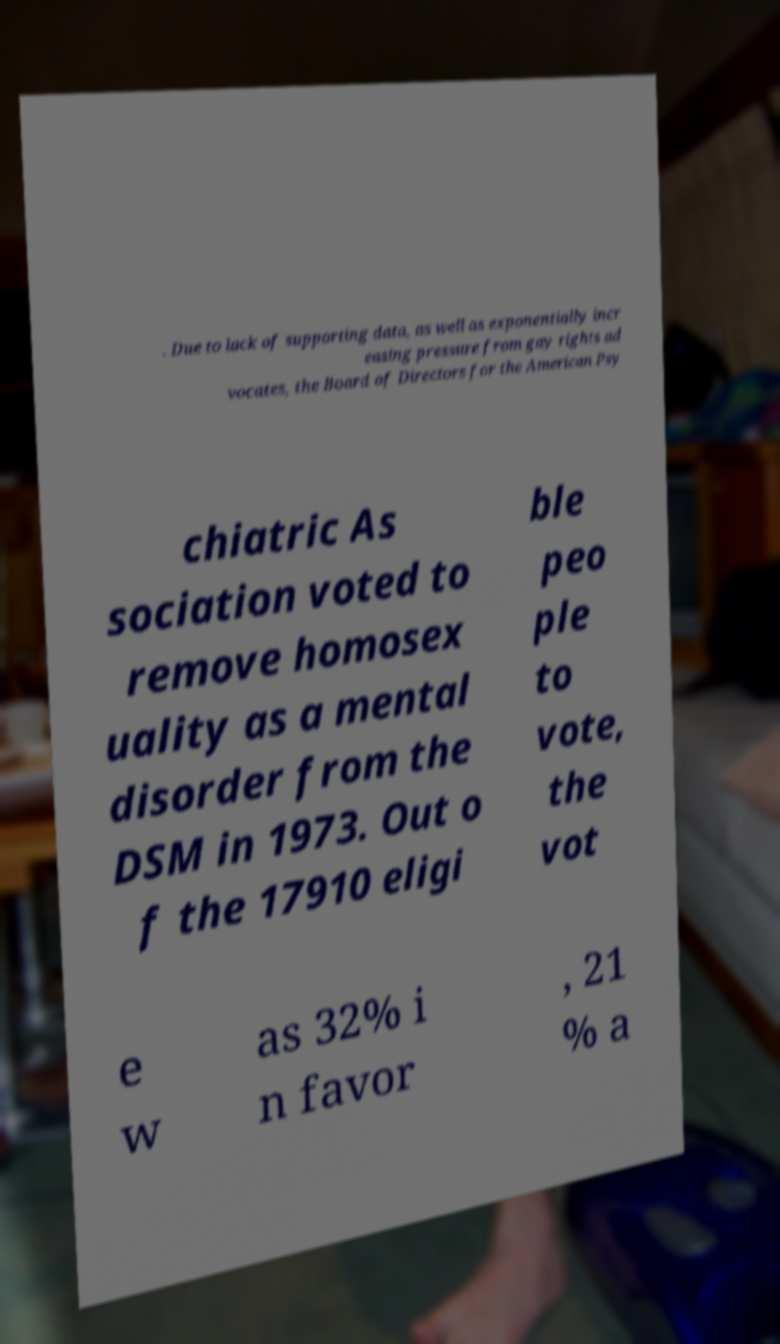There's text embedded in this image that I need extracted. Can you transcribe it verbatim? . Due to lack of supporting data, as well as exponentially incr easing pressure from gay rights ad vocates, the Board of Directors for the American Psy chiatric As sociation voted to remove homosex uality as a mental disorder from the DSM in 1973. Out o f the 17910 eligi ble peo ple to vote, the vot e w as 32% i n favor , 21 % a 